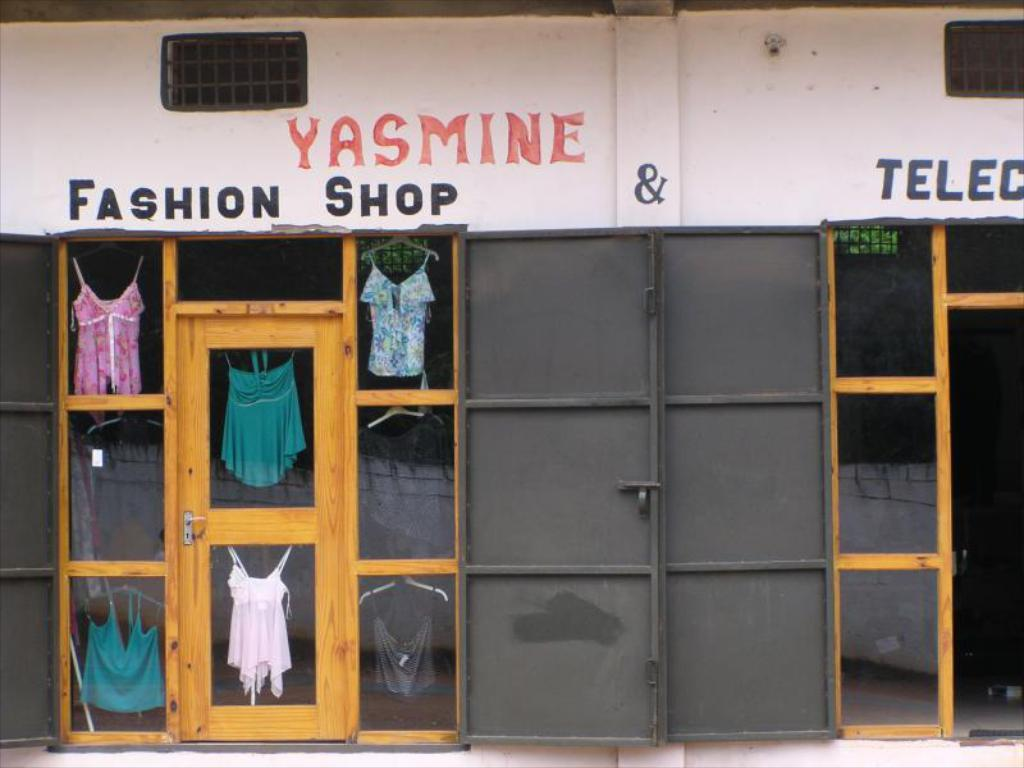<image>
Create a compact narrative representing the image presented. A few clothing items visible in the windows of Yasmine's Fashion Shop. 